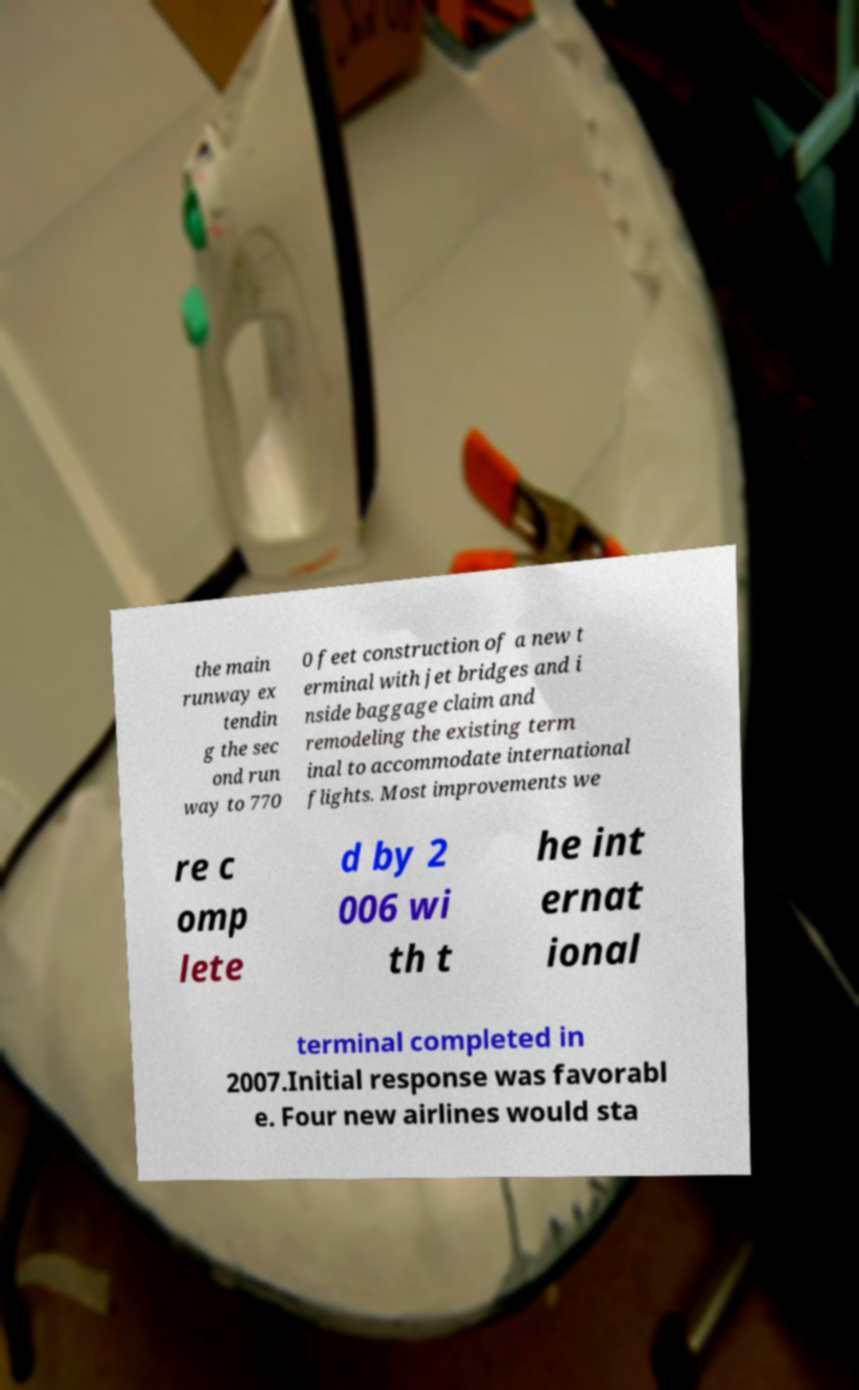There's text embedded in this image that I need extracted. Can you transcribe it verbatim? the main runway ex tendin g the sec ond run way to 770 0 feet construction of a new t erminal with jet bridges and i nside baggage claim and remodeling the existing term inal to accommodate international flights. Most improvements we re c omp lete d by 2 006 wi th t he int ernat ional terminal completed in 2007.Initial response was favorabl e. Four new airlines would sta 